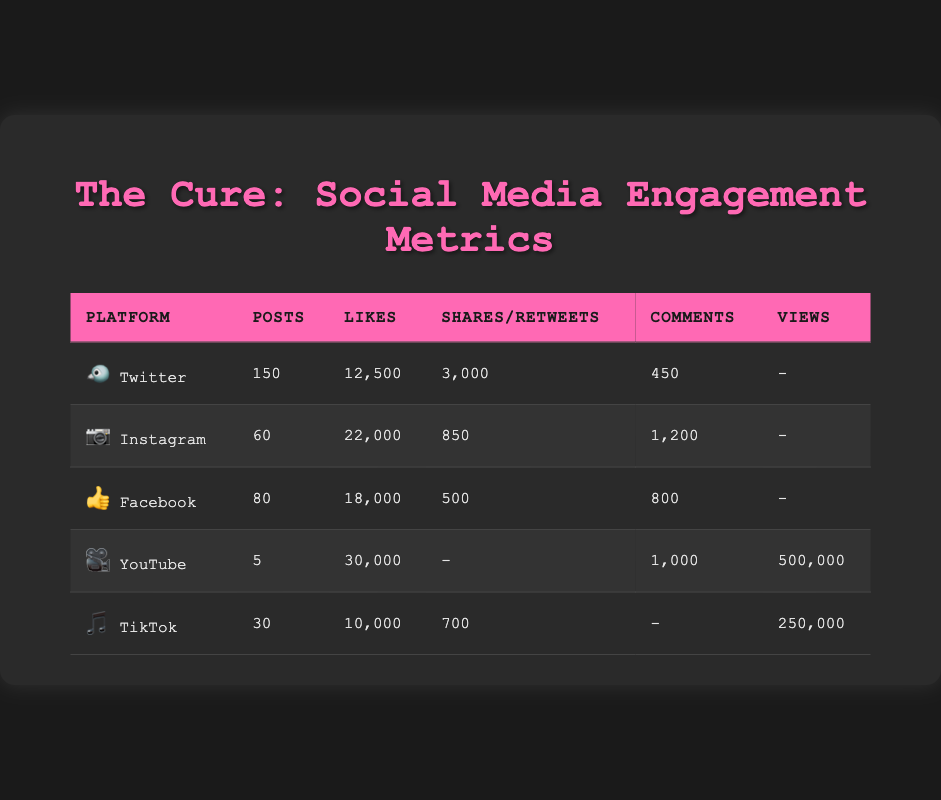What is the total number of Likes across all platforms? To find the total Likes, sum the Likes from each platform: Twitter (12,500) + Instagram (22,000) + Facebook (18,000) + YouTube (30,000) + TikTok (10,000) = 92,500.
Answer: 92,500 Which platform has the highest number of Comments? By comparing the Comments across all platforms, we see that Instagram has 1,200 Comments, YouTube has 1,000, Facebook has 800, Twitter has 450, and TikTok has none. Therefore, Instagram has the highest number of Comments.
Answer: Instagram Does Facebook have more Likes than TikTok? Facebook has 18,000 Likes and TikTok has 10,000 Likes. Since 18,000 is greater than 10,000, Facebook does have more Likes than TikTok.
Answer: Yes What is the average number of Posts across all platforms? To find the average number of Posts, first sum the Post counts: Twitter (150) + Instagram (60) + Facebook (80) + TikTok (30) = 320. Then, divide by the number of platforms (5): 320 / 5 = 64.
Answer: 64 How many more Retweets does Twitter have compared to Shares on Instagram? Twitter has 3,000 Retweets and Instagram has 850 Shares. To find the difference, subtract the Shares from the Retweets: 3,000 - 850 = 2,150.
Answer: 2,150 On which platform did The Cure receive the least number of Posts? From inspecting the Post counts: Twitter (150), Instagram (60), Facebook (80), YouTube (5), TikTok (30), it's clear YouTube has the least number of Posts with only 5.
Answer: YouTube Is the number of Views on YouTube greater than the cumulative Views on TikTok? YouTube has 500,000 Views, and TikTok has 250,000 Views. Since 500,000 is greater than 250,000, we can conclude that YouTube has more Views than TikTok.
Answer: Yes What is the total number of Shares (including Retweets) across Twitter and Facebook? Twitter has 3,000 Retweets, while Facebook has 500 Shares. To find the total, add both: 3,000 + 500 = 3,500.
Answer: 3,500 Which platform had the lowest engagement in terms of Posts and Comments combined? Combine the Posts and Comments for each platform: Twitter (150 + 450 = 600), Instagram (60 + 1,200 = 1,260), Facebook (80 + 800 = 880), YouTube (5 + 1,000 = 1,005), TikTok (30 + 0 = 30). The lowest combined engagement is for TikTok.
Answer: TikTok 